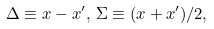Convert formula to latex. <formula><loc_0><loc_0><loc_500><loc_500>\Delta \equiv x - x ^ { \prime } , \, \Sigma \equiv ( x + x ^ { \prime } ) / 2 ,</formula> 